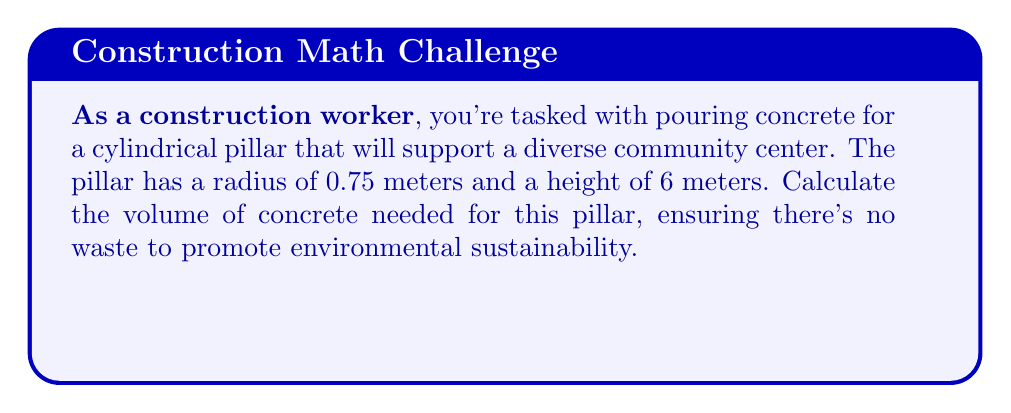Teach me how to tackle this problem. To calculate the volume of a cylindrical concrete pillar, we use the formula for the volume of a cylinder:

$$V = \pi r^2 h$$

Where:
$V$ = volume
$r$ = radius of the base
$h$ = height of the cylinder

Given:
$r = 0.75$ meters
$h = 6$ meters

Let's substitute these values into the formula:

$$\begin{align}
V &= \pi (0.75\text{ m})^2 (6\text{ m}) \\
&= \pi (0.5625\text{ m}^2) (6\text{ m}) \\
&= 3.375\pi\text{ m}^3 \\
&\approx 10.6029\text{ m}^3
\end{align}$$

Rounding to two decimal places for practical purposes:

$$V \approx 10.60\text{ m}^3$$

This is the volume of concrete needed for the pillar.
Answer: $10.60\text{ m}^3$ 